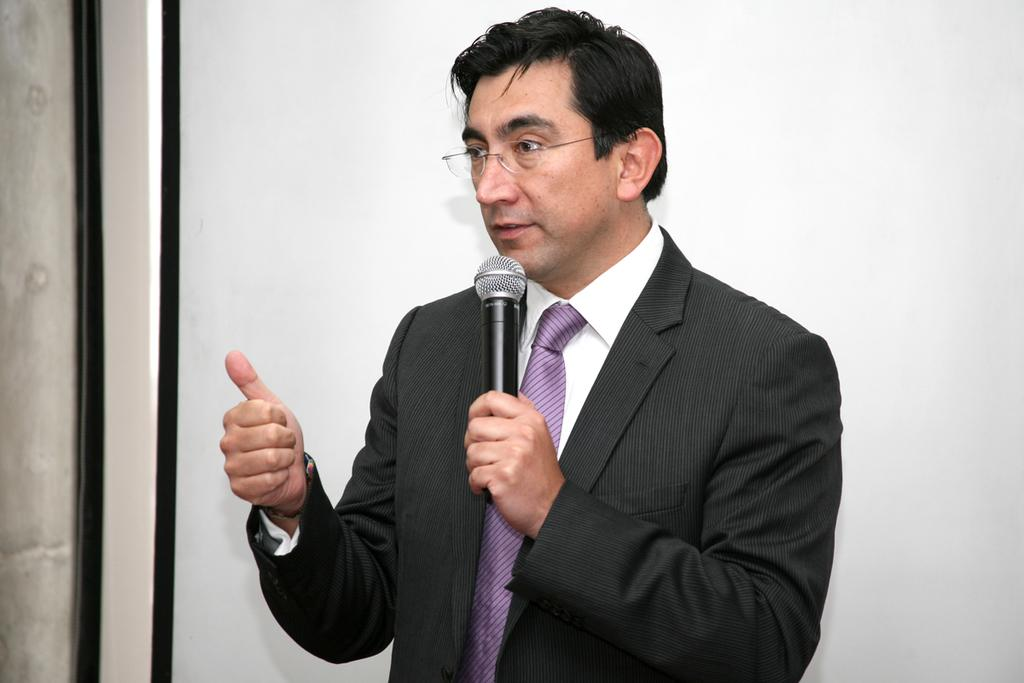What is the main subject of the image? There is a person in the image. What is the person holding in the image? The person is holding a microphone. What color is the background of the image? The background of the image is white. What can be seen on the left side of the image? There is a black colored object on the left side of the image. What type of hook is the person using to express their thoughts in the image? There is no hook present in the image, and the person is not expressing any thoughts. 